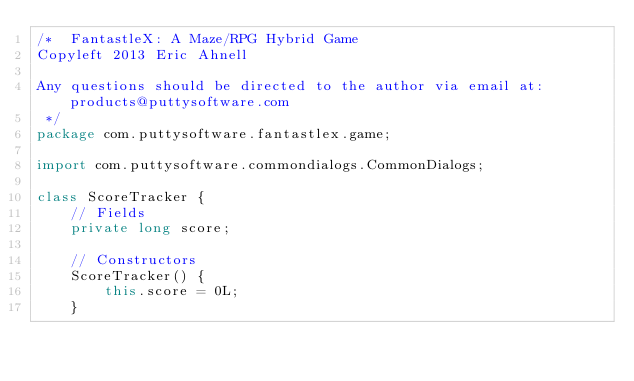<code> <loc_0><loc_0><loc_500><loc_500><_Java_>/*  FantastleX: A Maze/RPG Hybrid Game
Copyleft 2013 Eric Ahnell

Any questions should be directed to the author via email at: products@puttysoftware.com
 */
package com.puttysoftware.fantastlex.game;

import com.puttysoftware.commondialogs.CommonDialogs;

class ScoreTracker {
    // Fields
    private long score;

    // Constructors
    ScoreTracker() {
        this.score = 0L;
    }
</code> 